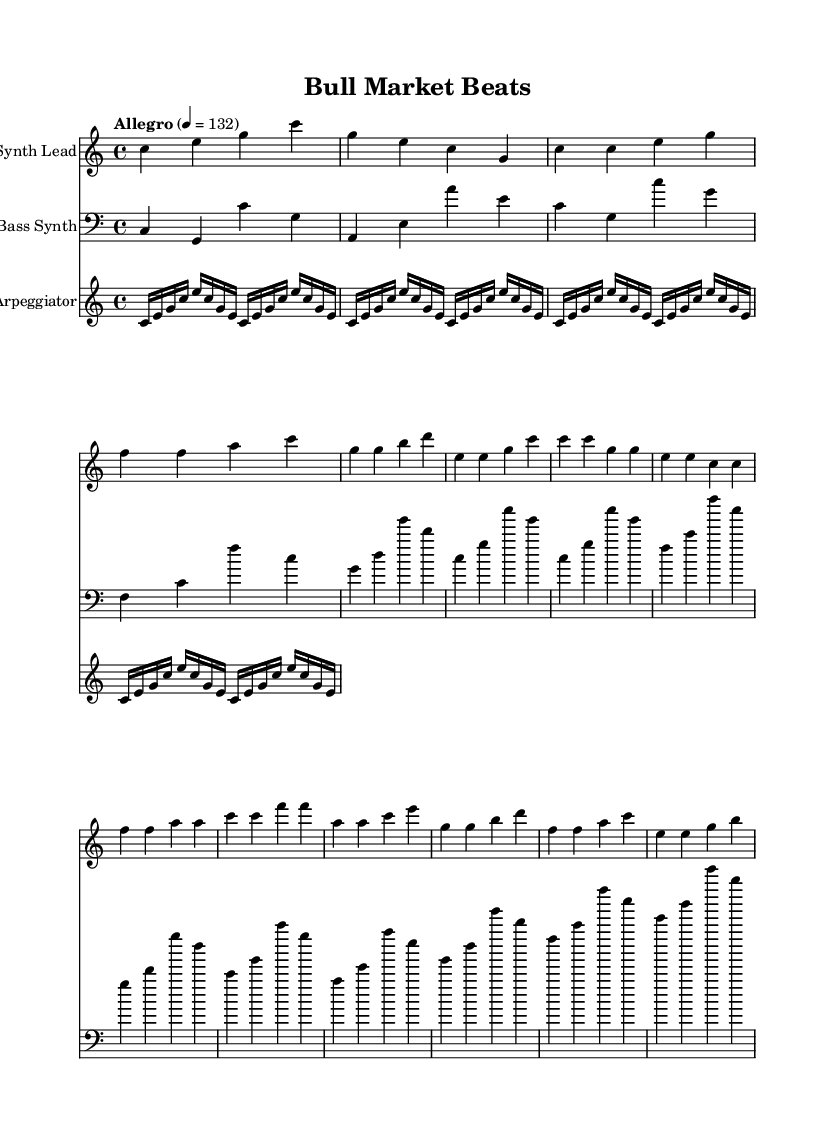What is the key signature of this music? The key signature is C major, which has no sharps or flats.
Answer: C major What is the time signature of this music? The time signature is indicated by the number of beats in each measure; in this case, it is four beats per measure as shown by the 4/4 notation.
Answer: 4/4 What is the tempo marking for this piece? The tempo marking "Allegro" suggests a fast tempo, and the number 132 indicates the beats per minute.
Answer: Allegro 132 How many sections are there in the arrangement? By analyzing the structure, there are three main sections: Intro, Verse, Chorus, and a Bridge that acts as a transition.
Answer: Four sections What are the names of the instruments used in the score? The score includes three staff sections labeled as "Synth Lead," "Bass Synth," and "Arpeggiator," indicating the instruments used.
Answer: Synth Lead, Bass Synth, Arpeggiator In which section does the arpeggiator pattern first appear? The arpeggiator pattern is introduced directly after the global settings and plays consistently throughout but is first noted in the total composition during the Verse section, blending with the lead synth.
Answer: Verse What is the chord progression used in the Chorus? The Chorus features a specific pattern: C C G G E E C C and F F A A C C F F, which indicates the harmonic motion generating an uplifting feel.
Answer: C C G G E E C C, F F A A C C F F 